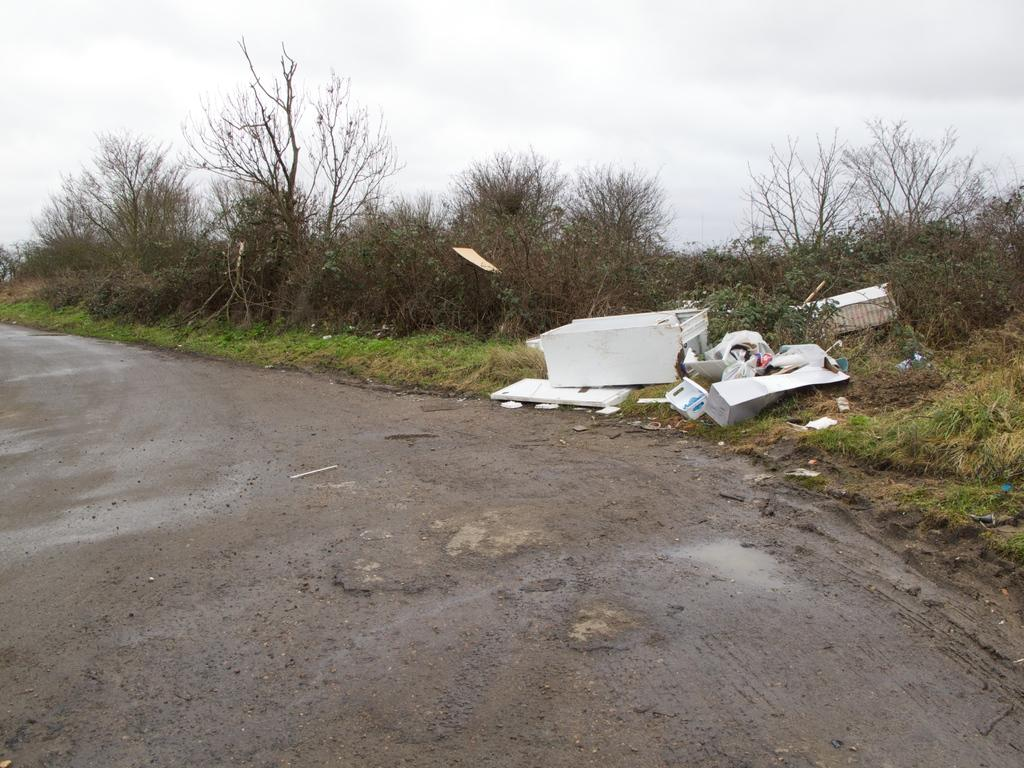What is the main feature of the image? There is a road in the image. What objects can be seen alongside the road? There are broken boxes in the image. What type of vegetation is present in the image? There are trees and grass in the image. Can you see a squirrel eating celery on the side of the road in the image? There is no squirrel or celery present in the image. Are there any flies buzzing around the broken boxes in the image? There is no mention of flies in the image, so we cannot determine their presence. 